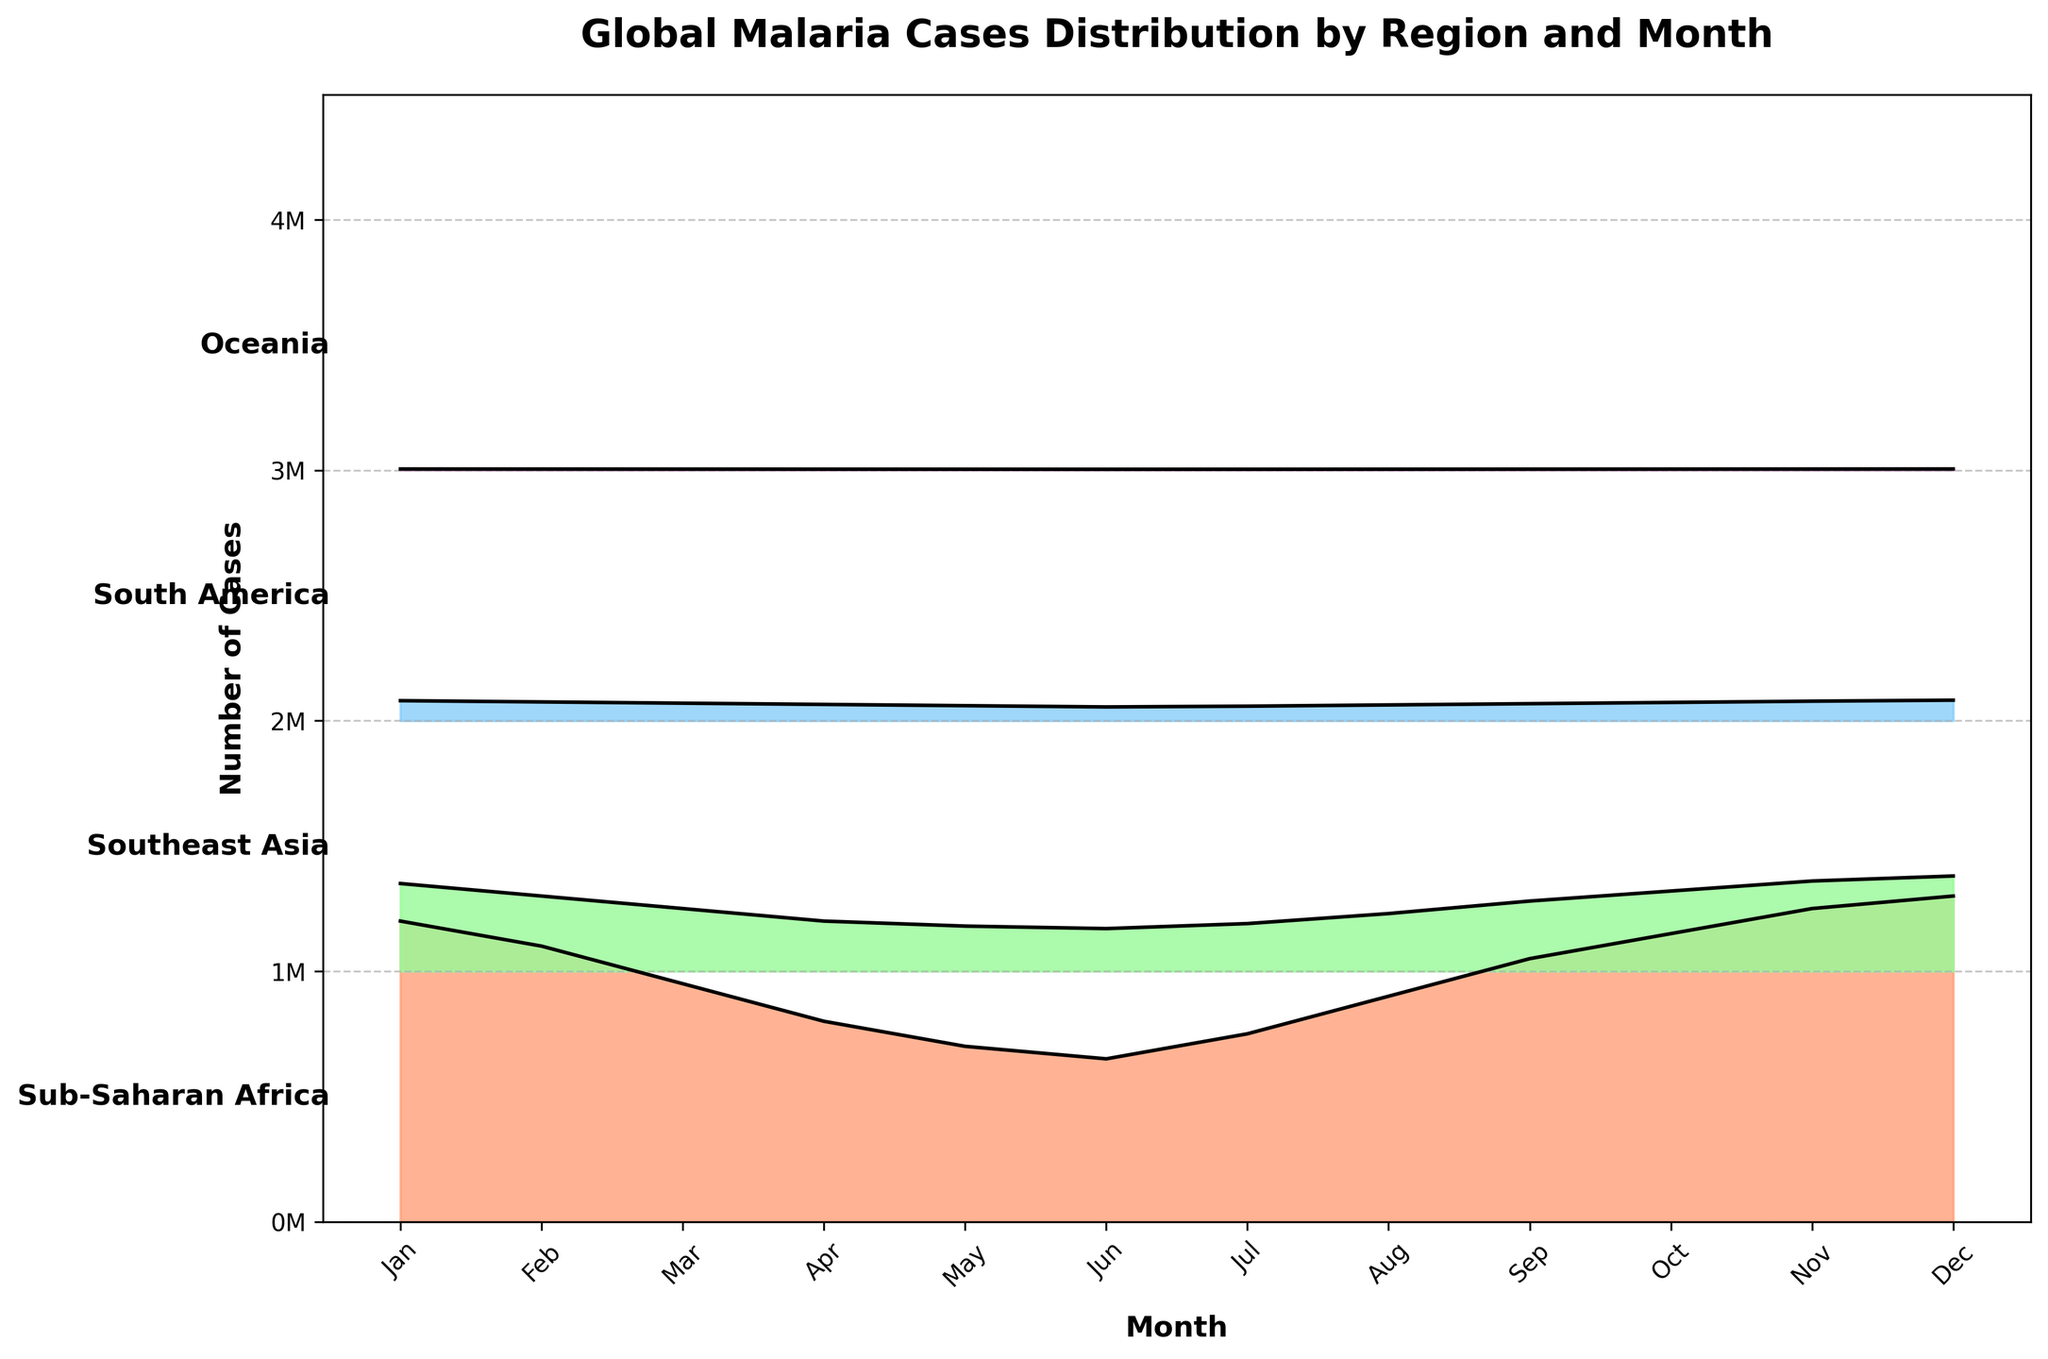Which region has the highest number of malaria cases in December? Look at December on the x-axis and check which region (y-axis) has the highest 'ridge' peak. Sub-Saharan Africa has the highest peak for December.
Answer: Sub-Saharan Africa What is the general trend of malaria cases in Southeast Asia throughout the year? Observe the line for Southeast Asia. The peak is at 350,000 in January, the lowest at 170,000 in June, and it rises back to 380,000 in December.
Answer: Decreasing mid-year, then increasing Which region shows the least number of malaria cases consistently throughout the year? Look for the region with the smallest ridges in all months. Oceania has the smallest ridges throughout the year.
Answer: Oceania What is the maximum number of malaria cases observed in South America in any month? Check for the highest ridge peak for South America from January to December. The highest is in December at 82,000 cases.
Answer: 82,000 How do the malaria cases in Sub-Saharan Africa in April compare to May? Locate these months for Sub-Saharan Africa and compare the heights of the ridges. April shows 800,000, while May shows 700,000. April is higher.
Answer: April is higher Which region has the smallest range of malaria cases throughout the year? Calculate the difference between the highest and lowest cases for each region. Oceania ranges from 4,000 to 5,100 (a range of 1,100). This is the smallest.
Answer: Oceania In which month does Sub-Saharan Africa experience the lowest number of malaria cases? Look for the lowest ridge in the Sub-Saharan Africa series. The lowest point is in June with 650,000 cases.
Answer: June By how much do malaria cases in Sub-Saharan Africa exceed those in Southeast Asia in November? Note the numbers for both regions in November: Sub-Saharan Africa has 1,250,000 and Southeast Asia has 360,000. Subtract Southeast Asia's numbers from Sub-Saharan Africa's.
Answer: 890,000 In which month is the difference between malaria cases in South America and Oceania the largest? Calculate the differences month-by-month and identify the month with the largest difference. December shows the largest difference. (82,000 - 5,100)
Answer: December What is the average number of cases in Southeast Asia from June to August? Sum the cases from June (170,000), July (190,000), and August (230,000) and divide by 3. (170,000 + 190,000 + 230,000) / 3
Answer: 196,667 